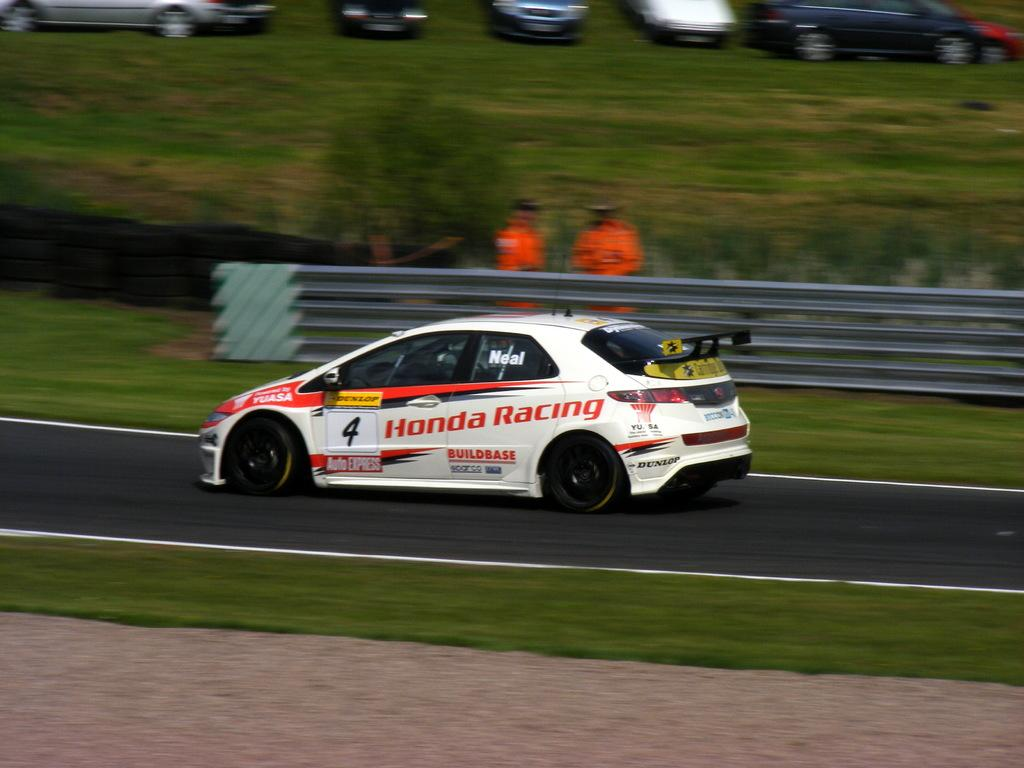<image>
Render a clear and concise summary of the photo. A white racing car on a track with Honda Racing and 4 on the side. 